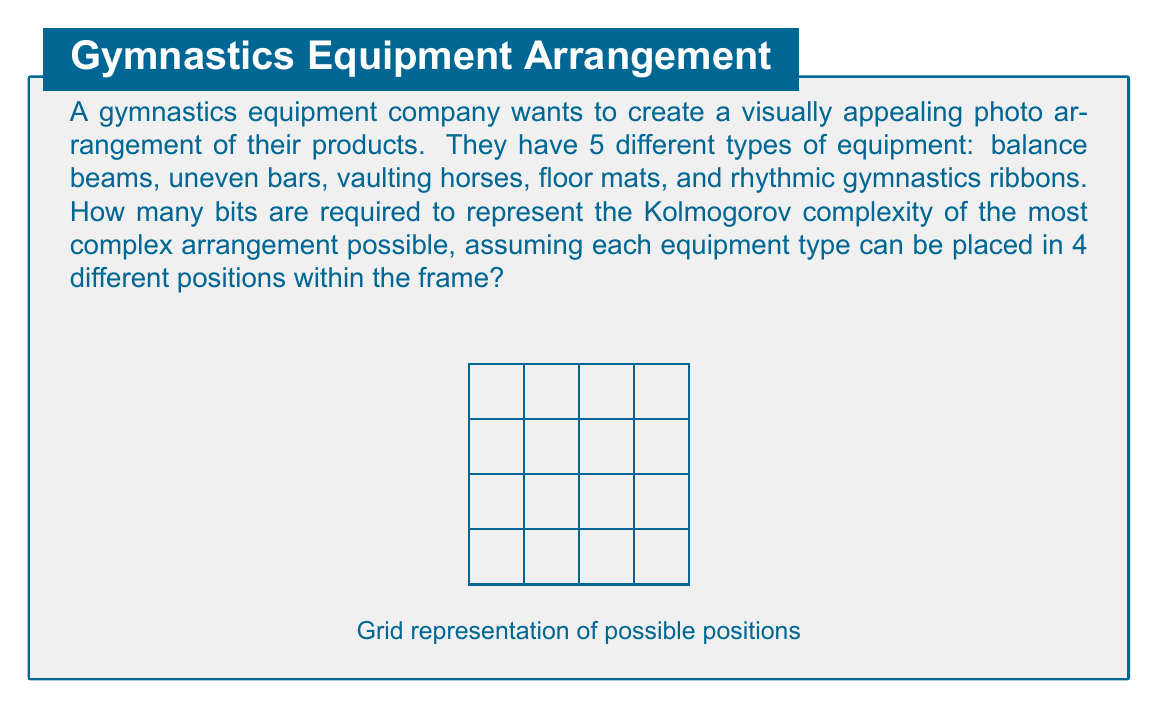Show me your answer to this math problem. To solve this problem, we need to follow these steps:

1) First, let's calculate the total number of possible arrangements:
   - We have 5 types of equipment
   - Each type can be placed in 4 different positions
   - Therefore, the total number of arrangements is $4^5 = 1024$

2) The Kolmogorov complexity represents the length of the shortest program that can generate a specific arrangement. In the worst case (most complex arrangement), this would be equivalent to simply listing the positions of each piece of equipment.

3) To represent each piece of equipment's position, we need 2 bits (as there are 4 positions, and $2^2 = 4$):
   $$5 \text{ equipment types} \times 2 \text{ bits per position} = 10 \text{ bits}$$

4) However, the question asks for the number of bits required to represent the Kolmogorov complexity. This means we need to calculate $\log_2$ of the total number of arrangements:

   $$\log_2(4^5) = 5 \log_2(4) = 5 \times 2 = 10 \text{ bits}$$

5) This result matches our intuition from step 3, confirming that 10 bits are indeed sufficient to uniquely identify any arrangement in this setup.
Answer: 10 bits 